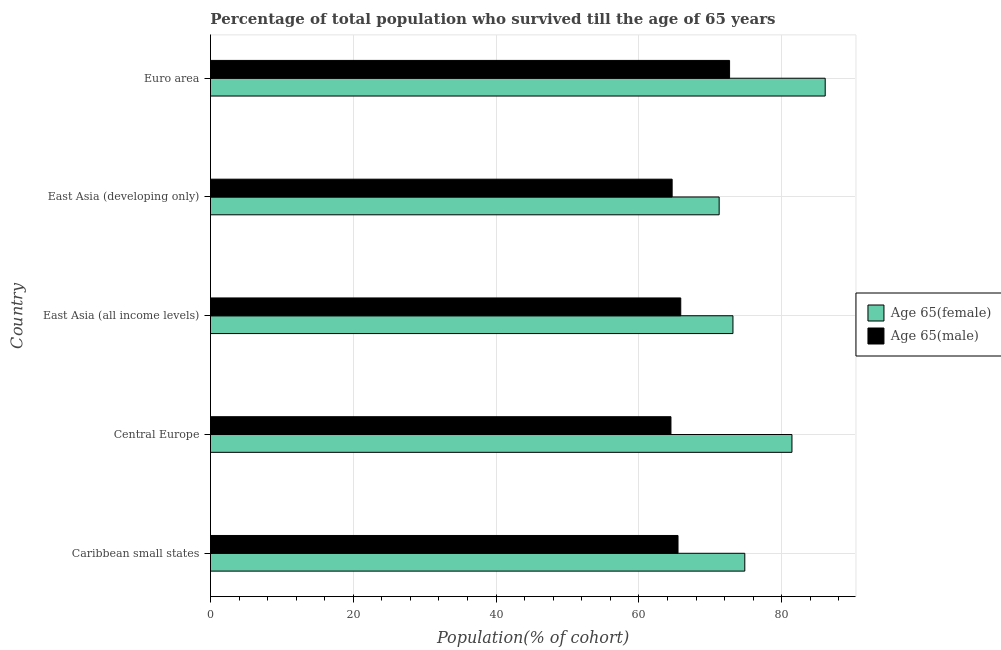How many groups of bars are there?
Your answer should be compact. 5. Are the number of bars per tick equal to the number of legend labels?
Make the answer very short. Yes. How many bars are there on the 5th tick from the bottom?
Give a very brief answer. 2. What is the label of the 5th group of bars from the top?
Provide a short and direct response. Caribbean small states. In how many cases, is the number of bars for a given country not equal to the number of legend labels?
Provide a short and direct response. 0. What is the percentage of male population who survived till age of 65 in Euro area?
Your response must be concise. 72.7. Across all countries, what is the maximum percentage of female population who survived till age of 65?
Offer a very short reply. 86.09. Across all countries, what is the minimum percentage of female population who survived till age of 65?
Offer a terse response. 71.24. In which country was the percentage of female population who survived till age of 65 maximum?
Your answer should be compact. Euro area. In which country was the percentage of female population who survived till age of 65 minimum?
Your answer should be very brief. East Asia (developing only). What is the total percentage of male population who survived till age of 65 in the graph?
Offer a terse response. 333.18. What is the difference between the percentage of female population who survived till age of 65 in East Asia (all income levels) and that in East Asia (developing only)?
Give a very brief answer. 1.93. What is the difference between the percentage of female population who survived till age of 65 in Central Europe and the percentage of male population who survived till age of 65 in Euro area?
Make the answer very short. 8.74. What is the average percentage of male population who survived till age of 65 per country?
Keep it short and to the point. 66.64. What is the difference between the percentage of female population who survived till age of 65 and percentage of male population who survived till age of 65 in East Asia (developing only)?
Your answer should be very brief. 6.58. What is the ratio of the percentage of female population who survived till age of 65 in East Asia (all income levels) to that in East Asia (developing only)?
Provide a succinct answer. 1.03. What is the difference between the highest and the second highest percentage of female population who survived till age of 65?
Your answer should be compact. 4.66. What is the difference between the highest and the lowest percentage of male population who survived till age of 65?
Provide a short and direct response. 8.21. Is the sum of the percentage of male population who survived till age of 65 in Caribbean small states and Central Europe greater than the maximum percentage of female population who survived till age of 65 across all countries?
Ensure brevity in your answer.  Yes. What does the 2nd bar from the top in East Asia (developing only) represents?
Ensure brevity in your answer.  Age 65(female). What does the 2nd bar from the bottom in Caribbean small states represents?
Ensure brevity in your answer.  Age 65(male). How many countries are there in the graph?
Make the answer very short. 5. What is the difference between two consecutive major ticks on the X-axis?
Provide a succinct answer. 20. Does the graph contain grids?
Your response must be concise. Yes. How many legend labels are there?
Make the answer very short. 2. How are the legend labels stacked?
Your answer should be very brief. Vertical. What is the title of the graph?
Your answer should be compact. Percentage of total population who survived till the age of 65 years. Does "Electricity" appear as one of the legend labels in the graph?
Ensure brevity in your answer.  No. What is the label or title of the X-axis?
Your answer should be compact. Population(% of cohort). What is the Population(% of cohort) in Age 65(female) in Caribbean small states?
Provide a short and direct response. 74.83. What is the Population(% of cohort) of Age 65(male) in Caribbean small states?
Keep it short and to the point. 65.48. What is the Population(% of cohort) of Age 65(female) in Central Europe?
Ensure brevity in your answer.  81.43. What is the Population(% of cohort) in Age 65(male) in Central Europe?
Offer a terse response. 64.49. What is the Population(% of cohort) in Age 65(female) in East Asia (all income levels)?
Give a very brief answer. 73.17. What is the Population(% of cohort) of Age 65(male) in East Asia (all income levels)?
Keep it short and to the point. 65.86. What is the Population(% of cohort) in Age 65(female) in East Asia (developing only)?
Provide a succinct answer. 71.24. What is the Population(% of cohort) in Age 65(male) in East Asia (developing only)?
Your response must be concise. 64.65. What is the Population(% of cohort) in Age 65(female) in Euro area?
Make the answer very short. 86.09. What is the Population(% of cohort) of Age 65(male) in Euro area?
Offer a terse response. 72.7. Across all countries, what is the maximum Population(% of cohort) of Age 65(female)?
Your answer should be very brief. 86.09. Across all countries, what is the maximum Population(% of cohort) in Age 65(male)?
Your answer should be very brief. 72.7. Across all countries, what is the minimum Population(% of cohort) of Age 65(female)?
Your answer should be compact. 71.24. Across all countries, what is the minimum Population(% of cohort) in Age 65(male)?
Provide a short and direct response. 64.49. What is the total Population(% of cohort) in Age 65(female) in the graph?
Your answer should be very brief. 386.76. What is the total Population(% of cohort) in Age 65(male) in the graph?
Provide a short and direct response. 333.18. What is the difference between the Population(% of cohort) of Age 65(female) in Caribbean small states and that in Central Europe?
Ensure brevity in your answer.  -6.61. What is the difference between the Population(% of cohort) in Age 65(female) in Caribbean small states and that in East Asia (all income levels)?
Give a very brief answer. 1.66. What is the difference between the Population(% of cohort) of Age 65(male) in Caribbean small states and that in East Asia (all income levels)?
Offer a terse response. -0.38. What is the difference between the Population(% of cohort) in Age 65(female) in Caribbean small states and that in East Asia (developing only)?
Keep it short and to the point. 3.59. What is the difference between the Population(% of cohort) in Age 65(male) in Caribbean small states and that in East Asia (developing only)?
Provide a short and direct response. 0.82. What is the difference between the Population(% of cohort) of Age 65(female) in Caribbean small states and that in Euro area?
Your response must be concise. -11.26. What is the difference between the Population(% of cohort) in Age 65(male) in Caribbean small states and that in Euro area?
Make the answer very short. -7.22. What is the difference between the Population(% of cohort) of Age 65(female) in Central Europe and that in East Asia (all income levels)?
Your answer should be very brief. 8.26. What is the difference between the Population(% of cohort) in Age 65(male) in Central Europe and that in East Asia (all income levels)?
Your answer should be compact. -1.37. What is the difference between the Population(% of cohort) in Age 65(female) in Central Europe and that in East Asia (developing only)?
Your answer should be compact. 10.2. What is the difference between the Population(% of cohort) in Age 65(male) in Central Europe and that in East Asia (developing only)?
Keep it short and to the point. -0.17. What is the difference between the Population(% of cohort) in Age 65(female) in Central Europe and that in Euro area?
Ensure brevity in your answer.  -4.66. What is the difference between the Population(% of cohort) in Age 65(male) in Central Europe and that in Euro area?
Provide a short and direct response. -8.21. What is the difference between the Population(% of cohort) in Age 65(female) in East Asia (all income levels) and that in East Asia (developing only)?
Offer a very short reply. 1.93. What is the difference between the Population(% of cohort) in Age 65(male) in East Asia (all income levels) and that in East Asia (developing only)?
Your answer should be compact. 1.2. What is the difference between the Population(% of cohort) in Age 65(female) in East Asia (all income levels) and that in Euro area?
Offer a very short reply. -12.92. What is the difference between the Population(% of cohort) of Age 65(male) in East Asia (all income levels) and that in Euro area?
Ensure brevity in your answer.  -6.84. What is the difference between the Population(% of cohort) of Age 65(female) in East Asia (developing only) and that in Euro area?
Your answer should be compact. -14.85. What is the difference between the Population(% of cohort) of Age 65(male) in East Asia (developing only) and that in Euro area?
Offer a terse response. -8.04. What is the difference between the Population(% of cohort) in Age 65(female) in Caribbean small states and the Population(% of cohort) in Age 65(male) in Central Europe?
Your answer should be very brief. 10.34. What is the difference between the Population(% of cohort) in Age 65(female) in Caribbean small states and the Population(% of cohort) in Age 65(male) in East Asia (all income levels)?
Your answer should be compact. 8.97. What is the difference between the Population(% of cohort) in Age 65(female) in Caribbean small states and the Population(% of cohort) in Age 65(male) in East Asia (developing only)?
Offer a terse response. 10.17. What is the difference between the Population(% of cohort) in Age 65(female) in Caribbean small states and the Population(% of cohort) in Age 65(male) in Euro area?
Provide a short and direct response. 2.13. What is the difference between the Population(% of cohort) of Age 65(female) in Central Europe and the Population(% of cohort) of Age 65(male) in East Asia (all income levels)?
Give a very brief answer. 15.57. What is the difference between the Population(% of cohort) of Age 65(female) in Central Europe and the Population(% of cohort) of Age 65(male) in East Asia (developing only)?
Your response must be concise. 16.78. What is the difference between the Population(% of cohort) of Age 65(female) in Central Europe and the Population(% of cohort) of Age 65(male) in Euro area?
Your answer should be very brief. 8.74. What is the difference between the Population(% of cohort) of Age 65(female) in East Asia (all income levels) and the Population(% of cohort) of Age 65(male) in East Asia (developing only)?
Keep it short and to the point. 8.52. What is the difference between the Population(% of cohort) in Age 65(female) in East Asia (all income levels) and the Population(% of cohort) in Age 65(male) in Euro area?
Offer a very short reply. 0.47. What is the difference between the Population(% of cohort) of Age 65(female) in East Asia (developing only) and the Population(% of cohort) of Age 65(male) in Euro area?
Your answer should be compact. -1.46. What is the average Population(% of cohort) in Age 65(female) per country?
Your answer should be compact. 77.35. What is the average Population(% of cohort) in Age 65(male) per country?
Your response must be concise. 66.64. What is the difference between the Population(% of cohort) of Age 65(female) and Population(% of cohort) of Age 65(male) in Caribbean small states?
Offer a very short reply. 9.35. What is the difference between the Population(% of cohort) in Age 65(female) and Population(% of cohort) in Age 65(male) in Central Europe?
Your answer should be compact. 16.95. What is the difference between the Population(% of cohort) in Age 65(female) and Population(% of cohort) in Age 65(male) in East Asia (all income levels)?
Ensure brevity in your answer.  7.31. What is the difference between the Population(% of cohort) of Age 65(female) and Population(% of cohort) of Age 65(male) in East Asia (developing only)?
Offer a very short reply. 6.58. What is the difference between the Population(% of cohort) of Age 65(female) and Population(% of cohort) of Age 65(male) in Euro area?
Provide a short and direct response. 13.39. What is the ratio of the Population(% of cohort) in Age 65(female) in Caribbean small states to that in Central Europe?
Provide a short and direct response. 0.92. What is the ratio of the Population(% of cohort) of Age 65(male) in Caribbean small states to that in Central Europe?
Your response must be concise. 1.02. What is the ratio of the Population(% of cohort) in Age 65(female) in Caribbean small states to that in East Asia (all income levels)?
Ensure brevity in your answer.  1.02. What is the ratio of the Population(% of cohort) of Age 65(female) in Caribbean small states to that in East Asia (developing only)?
Your answer should be very brief. 1.05. What is the ratio of the Population(% of cohort) of Age 65(male) in Caribbean small states to that in East Asia (developing only)?
Give a very brief answer. 1.01. What is the ratio of the Population(% of cohort) of Age 65(female) in Caribbean small states to that in Euro area?
Keep it short and to the point. 0.87. What is the ratio of the Population(% of cohort) in Age 65(male) in Caribbean small states to that in Euro area?
Keep it short and to the point. 0.9. What is the ratio of the Population(% of cohort) in Age 65(female) in Central Europe to that in East Asia (all income levels)?
Your answer should be compact. 1.11. What is the ratio of the Population(% of cohort) of Age 65(male) in Central Europe to that in East Asia (all income levels)?
Your answer should be very brief. 0.98. What is the ratio of the Population(% of cohort) of Age 65(female) in Central Europe to that in East Asia (developing only)?
Your response must be concise. 1.14. What is the ratio of the Population(% of cohort) in Age 65(female) in Central Europe to that in Euro area?
Your response must be concise. 0.95. What is the ratio of the Population(% of cohort) of Age 65(male) in Central Europe to that in Euro area?
Provide a succinct answer. 0.89. What is the ratio of the Population(% of cohort) in Age 65(female) in East Asia (all income levels) to that in East Asia (developing only)?
Offer a terse response. 1.03. What is the ratio of the Population(% of cohort) of Age 65(male) in East Asia (all income levels) to that in East Asia (developing only)?
Keep it short and to the point. 1.02. What is the ratio of the Population(% of cohort) of Age 65(female) in East Asia (all income levels) to that in Euro area?
Your answer should be compact. 0.85. What is the ratio of the Population(% of cohort) in Age 65(male) in East Asia (all income levels) to that in Euro area?
Keep it short and to the point. 0.91. What is the ratio of the Population(% of cohort) in Age 65(female) in East Asia (developing only) to that in Euro area?
Provide a short and direct response. 0.83. What is the ratio of the Population(% of cohort) of Age 65(male) in East Asia (developing only) to that in Euro area?
Offer a very short reply. 0.89. What is the difference between the highest and the second highest Population(% of cohort) of Age 65(female)?
Make the answer very short. 4.66. What is the difference between the highest and the second highest Population(% of cohort) in Age 65(male)?
Offer a very short reply. 6.84. What is the difference between the highest and the lowest Population(% of cohort) of Age 65(female)?
Keep it short and to the point. 14.85. What is the difference between the highest and the lowest Population(% of cohort) in Age 65(male)?
Provide a short and direct response. 8.21. 